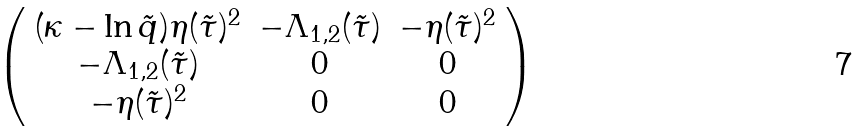Convert formula to latex. <formula><loc_0><loc_0><loc_500><loc_500>\left ( \begin{array} { c c c } ( \kappa - \ln \tilde { q } ) \eta ( \tilde { \tau } ) ^ { 2 } & - \Lambda _ { 1 , 2 } ( \tilde { \tau } ) & - \eta ( \tilde { \tau } ) ^ { 2 } \\ - \Lambda _ { 1 , 2 } ( \tilde { \tau } ) & 0 & 0 \\ - \eta ( \tilde { \tau } ) ^ { 2 } & 0 & 0 \end{array} \right )</formula> 